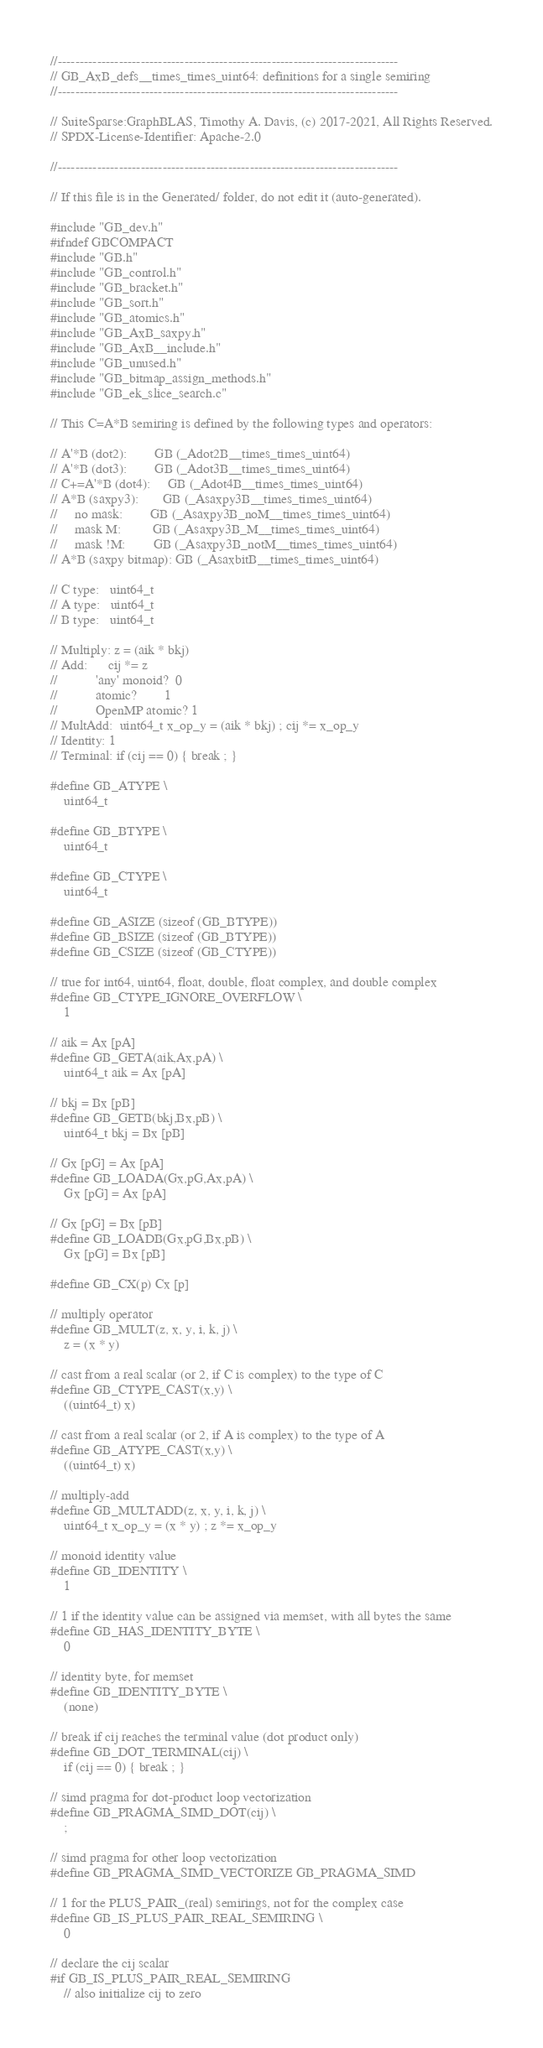Convert code to text. <code><loc_0><loc_0><loc_500><loc_500><_C_>//------------------------------------------------------------------------------
// GB_AxB_defs__times_times_uint64: definitions for a single semiring
//------------------------------------------------------------------------------

// SuiteSparse:GraphBLAS, Timothy A. Davis, (c) 2017-2021, All Rights Reserved.
// SPDX-License-Identifier: Apache-2.0

//------------------------------------------------------------------------------

// If this file is in the Generated/ folder, do not edit it (auto-generated).

#include "GB_dev.h"
#ifndef GBCOMPACT
#include "GB.h"
#include "GB_control.h"
#include "GB_bracket.h"
#include "GB_sort.h"
#include "GB_atomics.h"
#include "GB_AxB_saxpy.h"
#include "GB_AxB__include.h"
#include "GB_unused.h"
#include "GB_bitmap_assign_methods.h"
#include "GB_ek_slice_search.c"

// This C=A*B semiring is defined by the following types and operators:

// A'*B (dot2):        GB (_Adot2B__times_times_uint64)
// A'*B (dot3):        GB (_Adot3B__times_times_uint64)
// C+=A'*B (dot4):     GB (_Adot4B__times_times_uint64)
// A*B (saxpy3):       GB (_Asaxpy3B__times_times_uint64)
//     no mask:        GB (_Asaxpy3B_noM__times_times_uint64)
//     mask M:         GB (_Asaxpy3B_M__times_times_uint64)
//     mask !M:        GB (_Asaxpy3B_notM__times_times_uint64)
// A*B (saxpy bitmap): GB (_AsaxbitB__times_times_uint64)

// C type:   uint64_t
// A type:   uint64_t
// B type:   uint64_t

// Multiply: z = (aik * bkj)
// Add:      cij *= z
//           'any' monoid?  0
//           atomic?        1
//           OpenMP atomic? 1
// MultAdd:  uint64_t x_op_y = (aik * bkj) ; cij *= x_op_y
// Identity: 1
// Terminal: if (cij == 0) { break ; }

#define GB_ATYPE \
    uint64_t

#define GB_BTYPE \
    uint64_t

#define GB_CTYPE \
    uint64_t

#define GB_ASIZE (sizeof (GB_BTYPE))
#define GB_BSIZE (sizeof (GB_BTYPE))
#define GB_CSIZE (sizeof (GB_CTYPE))

// true for int64, uint64, float, double, float complex, and double complex 
#define GB_CTYPE_IGNORE_OVERFLOW \
    1

// aik = Ax [pA]
#define GB_GETA(aik,Ax,pA) \
    uint64_t aik = Ax [pA]

// bkj = Bx [pB]
#define GB_GETB(bkj,Bx,pB) \
    uint64_t bkj = Bx [pB]

// Gx [pG] = Ax [pA]
#define GB_LOADA(Gx,pG,Ax,pA) \
    Gx [pG] = Ax [pA]

// Gx [pG] = Bx [pB]
#define GB_LOADB(Gx,pG,Bx,pB) \
    Gx [pG] = Bx [pB]

#define GB_CX(p) Cx [p]

// multiply operator
#define GB_MULT(z, x, y, i, k, j) \
    z = (x * y)

// cast from a real scalar (or 2, if C is complex) to the type of C
#define GB_CTYPE_CAST(x,y) \
    ((uint64_t) x)

// cast from a real scalar (or 2, if A is complex) to the type of A
#define GB_ATYPE_CAST(x,y) \
    ((uint64_t) x)

// multiply-add
#define GB_MULTADD(z, x, y, i, k, j) \
    uint64_t x_op_y = (x * y) ; z *= x_op_y

// monoid identity value
#define GB_IDENTITY \
    1

// 1 if the identity value can be assigned via memset, with all bytes the same
#define GB_HAS_IDENTITY_BYTE \
    0

// identity byte, for memset
#define GB_IDENTITY_BYTE \
    (none)

// break if cij reaches the terminal value (dot product only)
#define GB_DOT_TERMINAL(cij) \
    if (cij == 0) { break ; }

// simd pragma for dot-product loop vectorization
#define GB_PRAGMA_SIMD_DOT(cij) \
    ;

// simd pragma for other loop vectorization
#define GB_PRAGMA_SIMD_VECTORIZE GB_PRAGMA_SIMD

// 1 for the PLUS_PAIR_(real) semirings, not for the complex case
#define GB_IS_PLUS_PAIR_REAL_SEMIRING \
    0

// declare the cij scalar
#if GB_IS_PLUS_PAIR_REAL_SEMIRING
    // also initialize cij to zero</code> 